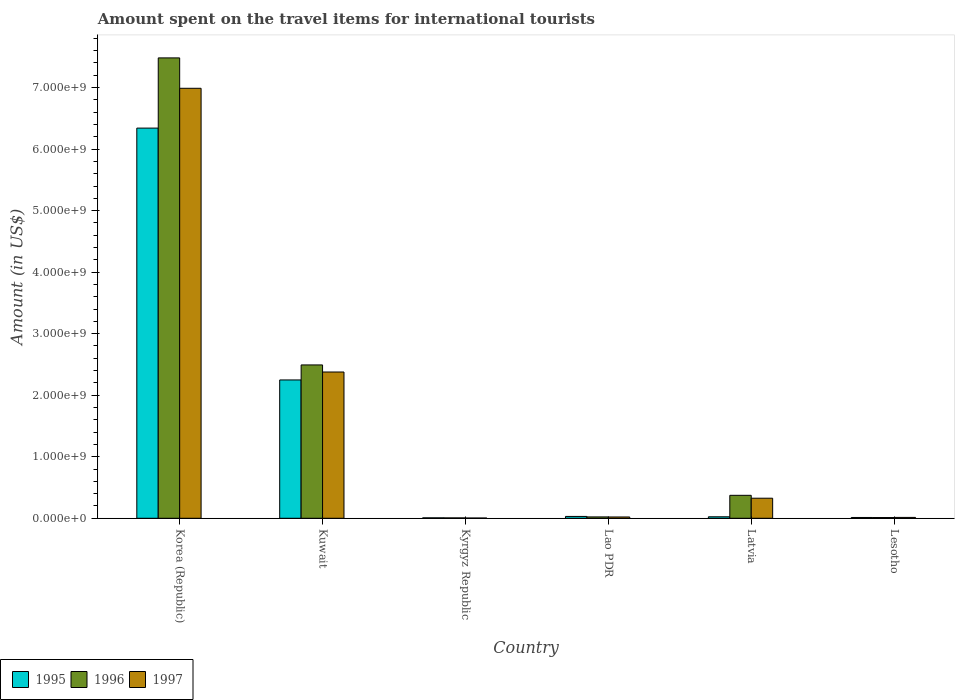How many different coloured bars are there?
Provide a succinct answer. 3. Are the number of bars on each tick of the X-axis equal?
Ensure brevity in your answer.  Yes. How many bars are there on the 6th tick from the left?
Make the answer very short. 3. What is the label of the 3rd group of bars from the left?
Offer a very short reply. Kyrgyz Republic. What is the amount spent on the travel items for international tourists in 1997 in Kuwait?
Your answer should be very brief. 2.38e+09. Across all countries, what is the maximum amount spent on the travel items for international tourists in 1995?
Make the answer very short. 6.34e+09. Across all countries, what is the minimum amount spent on the travel items for international tourists in 1995?
Offer a very short reply. 7.00e+06. In which country was the amount spent on the travel items for international tourists in 1996 maximum?
Offer a terse response. Korea (Republic). In which country was the amount spent on the travel items for international tourists in 1996 minimum?
Your response must be concise. Kyrgyz Republic. What is the total amount spent on the travel items for international tourists in 1996 in the graph?
Give a very brief answer. 1.04e+1. What is the difference between the amount spent on the travel items for international tourists in 1997 in Kuwait and that in Lesotho?
Your answer should be very brief. 2.36e+09. What is the difference between the amount spent on the travel items for international tourists in 1997 in Latvia and the amount spent on the travel items for international tourists in 1995 in Kuwait?
Offer a very short reply. -1.92e+09. What is the average amount spent on the travel items for international tourists in 1996 per country?
Provide a succinct answer. 1.73e+09. What is the difference between the amount spent on the travel items for international tourists of/in 1997 and amount spent on the travel items for international tourists of/in 1995 in Korea (Republic)?
Provide a short and direct response. 6.47e+08. What is the ratio of the amount spent on the travel items for international tourists in 1997 in Kuwait to that in Lesotho?
Your response must be concise. 169.79. Is the amount spent on the travel items for international tourists in 1996 in Korea (Republic) less than that in Lao PDR?
Provide a succinct answer. No. What is the difference between the highest and the second highest amount spent on the travel items for international tourists in 1995?
Provide a short and direct response. 4.09e+09. What is the difference between the highest and the lowest amount spent on the travel items for international tourists in 1996?
Keep it short and to the point. 7.48e+09. Is the sum of the amount spent on the travel items for international tourists in 1995 in Lao PDR and Latvia greater than the maximum amount spent on the travel items for international tourists in 1996 across all countries?
Give a very brief answer. No. What does the 3rd bar from the right in Lao PDR represents?
Give a very brief answer. 1995. Are all the bars in the graph horizontal?
Make the answer very short. No. What is the difference between two consecutive major ticks on the Y-axis?
Provide a short and direct response. 1.00e+09. Does the graph contain any zero values?
Offer a terse response. No. Does the graph contain grids?
Offer a very short reply. No. Where does the legend appear in the graph?
Offer a terse response. Bottom left. What is the title of the graph?
Ensure brevity in your answer.  Amount spent on the travel items for international tourists. What is the Amount (in US$) in 1995 in Korea (Republic)?
Your answer should be compact. 6.34e+09. What is the Amount (in US$) in 1996 in Korea (Republic)?
Give a very brief answer. 7.48e+09. What is the Amount (in US$) in 1997 in Korea (Republic)?
Offer a terse response. 6.99e+09. What is the Amount (in US$) of 1995 in Kuwait?
Ensure brevity in your answer.  2.25e+09. What is the Amount (in US$) of 1996 in Kuwait?
Ensure brevity in your answer.  2.49e+09. What is the Amount (in US$) in 1997 in Kuwait?
Ensure brevity in your answer.  2.38e+09. What is the Amount (in US$) in 1995 in Kyrgyz Republic?
Provide a short and direct response. 7.00e+06. What is the Amount (in US$) of 1995 in Lao PDR?
Your answer should be very brief. 3.00e+07. What is the Amount (in US$) of 1996 in Lao PDR?
Ensure brevity in your answer.  2.20e+07. What is the Amount (in US$) of 1997 in Lao PDR?
Give a very brief answer. 2.10e+07. What is the Amount (in US$) in 1995 in Latvia?
Provide a short and direct response. 2.40e+07. What is the Amount (in US$) of 1996 in Latvia?
Give a very brief answer. 3.73e+08. What is the Amount (in US$) of 1997 in Latvia?
Your answer should be compact. 3.26e+08. What is the Amount (in US$) in 1995 in Lesotho?
Your response must be concise. 1.30e+07. What is the Amount (in US$) of 1997 in Lesotho?
Provide a short and direct response. 1.40e+07. Across all countries, what is the maximum Amount (in US$) in 1995?
Provide a short and direct response. 6.34e+09. Across all countries, what is the maximum Amount (in US$) of 1996?
Your response must be concise. 7.48e+09. Across all countries, what is the maximum Amount (in US$) of 1997?
Give a very brief answer. 6.99e+09. Across all countries, what is the minimum Amount (in US$) in 1997?
Your answer should be very brief. 4.00e+06. What is the total Amount (in US$) in 1995 in the graph?
Your answer should be very brief. 8.66e+09. What is the total Amount (in US$) of 1996 in the graph?
Offer a very short reply. 1.04e+1. What is the total Amount (in US$) in 1997 in the graph?
Offer a terse response. 9.73e+09. What is the difference between the Amount (in US$) in 1995 in Korea (Republic) and that in Kuwait?
Ensure brevity in your answer.  4.09e+09. What is the difference between the Amount (in US$) in 1996 in Korea (Republic) and that in Kuwait?
Your response must be concise. 4.99e+09. What is the difference between the Amount (in US$) in 1997 in Korea (Republic) and that in Kuwait?
Your answer should be very brief. 4.61e+09. What is the difference between the Amount (in US$) of 1995 in Korea (Republic) and that in Kyrgyz Republic?
Ensure brevity in your answer.  6.33e+09. What is the difference between the Amount (in US$) of 1996 in Korea (Republic) and that in Kyrgyz Republic?
Offer a very short reply. 7.48e+09. What is the difference between the Amount (in US$) of 1997 in Korea (Republic) and that in Kyrgyz Republic?
Your response must be concise. 6.98e+09. What is the difference between the Amount (in US$) of 1995 in Korea (Republic) and that in Lao PDR?
Keep it short and to the point. 6.31e+09. What is the difference between the Amount (in US$) of 1996 in Korea (Republic) and that in Lao PDR?
Ensure brevity in your answer.  7.46e+09. What is the difference between the Amount (in US$) in 1997 in Korea (Republic) and that in Lao PDR?
Provide a short and direct response. 6.97e+09. What is the difference between the Amount (in US$) of 1995 in Korea (Republic) and that in Latvia?
Provide a short and direct response. 6.32e+09. What is the difference between the Amount (in US$) of 1996 in Korea (Republic) and that in Latvia?
Provide a short and direct response. 7.11e+09. What is the difference between the Amount (in US$) of 1997 in Korea (Republic) and that in Latvia?
Provide a short and direct response. 6.66e+09. What is the difference between the Amount (in US$) of 1995 in Korea (Republic) and that in Lesotho?
Your answer should be compact. 6.33e+09. What is the difference between the Amount (in US$) in 1996 in Korea (Republic) and that in Lesotho?
Provide a short and direct response. 7.47e+09. What is the difference between the Amount (in US$) of 1997 in Korea (Republic) and that in Lesotho?
Keep it short and to the point. 6.97e+09. What is the difference between the Amount (in US$) of 1995 in Kuwait and that in Kyrgyz Republic?
Keep it short and to the point. 2.24e+09. What is the difference between the Amount (in US$) in 1996 in Kuwait and that in Kyrgyz Republic?
Offer a terse response. 2.49e+09. What is the difference between the Amount (in US$) in 1997 in Kuwait and that in Kyrgyz Republic?
Ensure brevity in your answer.  2.37e+09. What is the difference between the Amount (in US$) in 1995 in Kuwait and that in Lao PDR?
Your answer should be compact. 2.22e+09. What is the difference between the Amount (in US$) in 1996 in Kuwait and that in Lao PDR?
Make the answer very short. 2.47e+09. What is the difference between the Amount (in US$) in 1997 in Kuwait and that in Lao PDR?
Provide a short and direct response. 2.36e+09. What is the difference between the Amount (in US$) of 1995 in Kuwait and that in Latvia?
Offer a terse response. 2.22e+09. What is the difference between the Amount (in US$) of 1996 in Kuwait and that in Latvia?
Offer a very short reply. 2.12e+09. What is the difference between the Amount (in US$) of 1997 in Kuwait and that in Latvia?
Offer a very short reply. 2.05e+09. What is the difference between the Amount (in US$) of 1995 in Kuwait and that in Lesotho?
Keep it short and to the point. 2.24e+09. What is the difference between the Amount (in US$) in 1996 in Kuwait and that in Lesotho?
Your answer should be compact. 2.48e+09. What is the difference between the Amount (in US$) in 1997 in Kuwait and that in Lesotho?
Provide a short and direct response. 2.36e+09. What is the difference between the Amount (in US$) in 1995 in Kyrgyz Republic and that in Lao PDR?
Offer a very short reply. -2.30e+07. What is the difference between the Amount (in US$) in 1996 in Kyrgyz Republic and that in Lao PDR?
Offer a terse response. -1.60e+07. What is the difference between the Amount (in US$) of 1997 in Kyrgyz Republic and that in Lao PDR?
Your answer should be compact. -1.70e+07. What is the difference between the Amount (in US$) in 1995 in Kyrgyz Republic and that in Latvia?
Provide a short and direct response. -1.70e+07. What is the difference between the Amount (in US$) of 1996 in Kyrgyz Republic and that in Latvia?
Give a very brief answer. -3.67e+08. What is the difference between the Amount (in US$) in 1997 in Kyrgyz Republic and that in Latvia?
Provide a succinct answer. -3.22e+08. What is the difference between the Amount (in US$) of 1995 in Kyrgyz Republic and that in Lesotho?
Provide a short and direct response. -6.00e+06. What is the difference between the Amount (in US$) of 1996 in Kyrgyz Republic and that in Lesotho?
Offer a terse response. -6.00e+06. What is the difference between the Amount (in US$) in 1997 in Kyrgyz Republic and that in Lesotho?
Your response must be concise. -1.00e+07. What is the difference between the Amount (in US$) in 1996 in Lao PDR and that in Latvia?
Give a very brief answer. -3.51e+08. What is the difference between the Amount (in US$) of 1997 in Lao PDR and that in Latvia?
Make the answer very short. -3.05e+08. What is the difference between the Amount (in US$) in 1995 in Lao PDR and that in Lesotho?
Provide a short and direct response. 1.70e+07. What is the difference between the Amount (in US$) of 1996 in Lao PDR and that in Lesotho?
Make the answer very short. 1.00e+07. What is the difference between the Amount (in US$) in 1997 in Lao PDR and that in Lesotho?
Offer a terse response. 7.00e+06. What is the difference between the Amount (in US$) in 1995 in Latvia and that in Lesotho?
Keep it short and to the point. 1.10e+07. What is the difference between the Amount (in US$) in 1996 in Latvia and that in Lesotho?
Your answer should be compact. 3.61e+08. What is the difference between the Amount (in US$) of 1997 in Latvia and that in Lesotho?
Keep it short and to the point. 3.12e+08. What is the difference between the Amount (in US$) in 1995 in Korea (Republic) and the Amount (in US$) in 1996 in Kuwait?
Offer a very short reply. 3.85e+09. What is the difference between the Amount (in US$) of 1995 in Korea (Republic) and the Amount (in US$) of 1997 in Kuwait?
Your answer should be very brief. 3.96e+09. What is the difference between the Amount (in US$) of 1996 in Korea (Republic) and the Amount (in US$) of 1997 in Kuwait?
Provide a succinct answer. 5.10e+09. What is the difference between the Amount (in US$) in 1995 in Korea (Republic) and the Amount (in US$) in 1996 in Kyrgyz Republic?
Your answer should be very brief. 6.34e+09. What is the difference between the Amount (in US$) of 1995 in Korea (Republic) and the Amount (in US$) of 1997 in Kyrgyz Republic?
Provide a short and direct response. 6.34e+09. What is the difference between the Amount (in US$) of 1996 in Korea (Republic) and the Amount (in US$) of 1997 in Kyrgyz Republic?
Provide a short and direct response. 7.48e+09. What is the difference between the Amount (in US$) of 1995 in Korea (Republic) and the Amount (in US$) of 1996 in Lao PDR?
Make the answer very short. 6.32e+09. What is the difference between the Amount (in US$) in 1995 in Korea (Republic) and the Amount (in US$) in 1997 in Lao PDR?
Give a very brief answer. 6.32e+09. What is the difference between the Amount (in US$) in 1996 in Korea (Republic) and the Amount (in US$) in 1997 in Lao PDR?
Offer a very short reply. 7.46e+09. What is the difference between the Amount (in US$) of 1995 in Korea (Republic) and the Amount (in US$) of 1996 in Latvia?
Your response must be concise. 5.97e+09. What is the difference between the Amount (in US$) in 1995 in Korea (Republic) and the Amount (in US$) in 1997 in Latvia?
Make the answer very short. 6.02e+09. What is the difference between the Amount (in US$) in 1996 in Korea (Republic) and the Amount (in US$) in 1997 in Latvia?
Provide a succinct answer. 7.16e+09. What is the difference between the Amount (in US$) of 1995 in Korea (Republic) and the Amount (in US$) of 1996 in Lesotho?
Your answer should be compact. 6.33e+09. What is the difference between the Amount (in US$) of 1995 in Korea (Republic) and the Amount (in US$) of 1997 in Lesotho?
Provide a short and direct response. 6.33e+09. What is the difference between the Amount (in US$) in 1996 in Korea (Republic) and the Amount (in US$) in 1997 in Lesotho?
Offer a very short reply. 7.47e+09. What is the difference between the Amount (in US$) in 1995 in Kuwait and the Amount (in US$) in 1996 in Kyrgyz Republic?
Offer a terse response. 2.24e+09. What is the difference between the Amount (in US$) of 1995 in Kuwait and the Amount (in US$) of 1997 in Kyrgyz Republic?
Your answer should be very brief. 2.24e+09. What is the difference between the Amount (in US$) in 1996 in Kuwait and the Amount (in US$) in 1997 in Kyrgyz Republic?
Keep it short and to the point. 2.49e+09. What is the difference between the Amount (in US$) of 1995 in Kuwait and the Amount (in US$) of 1996 in Lao PDR?
Offer a very short reply. 2.23e+09. What is the difference between the Amount (in US$) of 1995 in Kuwait and the Amount (in US$) of 1997 in Lao PDR?
Offer a terse response. 2.23e+09. What is the difference between the Amount (in US$) in 1996 in Kuwait and the Amount (in US$) in 1997 in Lao PDR?
Ensure brevity in your answer.  2.47e+09. What is the difference between the Amount (in US$) in 1995 in Kuwait and the Amount (in US$) in 1996 in Latvia?
Offer a very short reply. 1.88e+09. What is the difference between the Amount (in US$) in 1995 in Kuwait and the Amount (in US$) in 1997 in Latvia?
Your response must be concise. 1.92e+09. What is the difference between the Amount (in US$) in 1996 in Kuwait and the Amount (in US$) in 1997 in Latvia?
Your answer should be very brief. 2.17e+09. What is the difference between the Amount (in US$) in 1995 in Kuwait and the Amount (in US$) in 1996 in Lesotho?
Make the answer very short. 2.24e+09. What is the difference between the Amount (in US$) of 1995 in Kuwait and the Amount (in US$) of 1997 in Lesotho?
Make the answer very short. 2.23e+09. What is the difference between the Amount (in US$) in 1996 in Kuwait and the Amount (in US$) in 1997 in Lesotho?
Offer a terse response. 2.48e+09. What is the difference between the Amount (in US$) of 1995 in Kyrgyz Republic and the Amount (in US$) of 1996 in Lao PDR?
Keep it short and to the point. -1.50e+07. What is the difference between the Amount (in US$) of 1995 in Kyrgyz Republic and the Amount (in US$) of 1997 in Lao PDR?
Your answer should be very brief. -1.40e+07. What is the difference between the Amount (in US$) of 1996 in Kyrgyz Republic and the Amount (in US$) of 1997 in Lao PDR?
Your answer should be compact. -1.50e+07. What is the difference between the Amount (in US$) in 1995 in Kyrgyz Republic and the Amount (in US$) in 1996 in Latvia?
Keep it short and to the point. -3.66e+08. What is the difference between the Amount (in US$) in 1995 in Kyrgyz Republic and the Amount (in US$) in 1997 in Latvia?
Keep it short and to the point. -3.19e+08. What is the difference between the Amount (in US$) of 1996 in Kyrgyz Republic and the Amount (in US$) of 1997 in Latvia?
Your answer should be very brief. -3.20e+08. What is the difference between the Amount (in US$) in 1995 in Kyrgyz Republic and the Amount (in US$) in 1996 in Lesotho?
Make the answer very short. -5.00e+06. What is the difference between the Amount (in US$) in 1995 in Kyrgyz Republic and the Amount (in US$) in 1997 in Lesotho?
Your answer should be compact. -7.00e+06. What is the difference between the Amount (in US$) in 1996 in Kyrgyz Republic and the Amount (in US$) in 1997 in Lesotho?
Offer a terse response. -8.00e+06. What is the difference between the Amount (in US$) of 1995 in Lao PDR and the Amount (in US$) of 1996 in Latvia?
Your answer should be compact. -3.43e+08. What is the difference between the Amount (in US$) of 1995 in Lao PDR and the Amount (in US$) of 1997 in Latvia?
Provide a succinct answer. -2.96e+08. What is the difference between the Amount (in US$) in 1996 in Lao PDR and the Amount (in US$) in 1997 in Latvia?
Give a very brief answer. -3.04e+08. What is the difference between the Amount (in US$) of 1995 in Lao PDR and the Amount (in US$) of 1996 in Lesotho?
Your answer should be very brief. 1.80e+07. What is the difference between the Amount (in US$) in 1995 in Lao PDR and the Amount (in US$) in 1997 in Lesotho?
Offer a very short reply. 1.60e+07. What is the difference between the Amount (in US$) in 1996 in Lao PDR and the Amount (in US$) in 1997 in Lesotho?
Keep it short and to the point. 8.00e+06. What is the difference between the Amount (in US$) of 1995 in Latvia and the Amount (in US$) of 1996 in Lesotho?
Keep it short and to the point. 1.20e+07. What is the difference between the Amount (in US$) in 1996 in Latvia and the Amount (in US$) in 1997 in Lesotho?
Give a very brief answer. 3.59e+08. What is the average Amount (in US$) in 1995 per country?
Your response must be concise. 1.44e+09. What is the average Amount (in US$) in 1996 per country?
Your answer should be compact. 1.73e+09. What is the average Amount (in US$) in 1997 per country?
Provide a short and direct response. 1.62e+09. What is the difference between the Amount (in US$) of 1995 and Amount (in US$) of 1996 in Korea (Republic)?
Keep it short and to the point. -1.14e+09. What is the difference between the Amount (in US$) of 1995 and Amount (in US$) of 1997 in Korea (Republic)?
Offer a terse response. -6.47e+08. What is the difference between the Amount (in US$) of 1996 and Amount (in US$) of 1997 in Korea (Republic)?
Offer a terse response. 4.94e+08. What is the difference between the Amount (in US$) of 1995 and Amount (in US$) of 1996 in Kuwait?
Ensure brevity in your answer.  -2.44e+08. What is the difference between the Amount (in US$) in 1995 and Amount (in US$) in 1997 in Kuwait?
Offer a terse response. -1.29e+08. What is the difference between the Amount (in US$) in 1996 and Amount (in US$) in 1997 in Kuwait?
Offer a very short reply. 1.15e+08. What is the difference between the Amount (in US$) in 1995 and Amount (in US$) in 1997 in Kyrgyz Republic?
Ensure brevity in your answer.  3.00e+06. What is the difference between the Amount (in US$) of 1995 and Amount (in US$) of 1997 in Lao PDR?
Offer a very short reply. 9.00e+06. What is the difference between the Amount (in US$) of 1995 and Amount (in US$) of 1996 in Latvia?
Your response must be concise. -3.49e+08. What is the difference between the Amount (in US$) in 1995 and Amount (in US$) in 1997 in Latvia?
Your answer should be very brief. -3.02e+08. What is the difference between the Amount (in US$) of 1996 and Amount (in US$) of 1997 in Latvia?
Your response must be concise. 4.70e+07. What is the ratio of the Amount (in US$) in 1995 in Korea (Republic) to that in Kuwait?
Your answer should be compact. 2.82. What is the ratio of the Amount (in US$) in 1996 in Korea (Republic) to that in Kuwait?
Offer a very short reply. 3. What is the ratio of the Amount (in US$) of 1997 in Korea (Republic) to that in Kuwait?
Give a very brief answer. 2.94. What is the ratio of the Amount (in US$) in 1995 in Korea (Republic) to that in Kyrgyz Republic?
Offer a very short reply. 905.86. What is the ratio of the Amount (in US$) in 1996 in Korea (Republic) to that in Kyrgyz Republic?
Offer a very short reply. 1247. What is the ratio of the Amount (in US$) of 1997 in Korea (Republic) to that in Kyrgyz Republic?
Keep it short and to the point. 1747. What is the ratio of the Amount (in US$) in 1995 in Korea (Republic) to that in Lao PDR?
Your answer should be compact. 211.37. What is the ratio of the Amount (in US$) of 1996 in Korea (Republic) to that in Lao PDR?
Make the answer very short. 340.09. What is the ratio of the Amount (in US$) in 1997 in Korea (Republic) to that in Lao PDR?
Keep it short and to the point. 332.76. What is the ratio of the Amount (in US$) of 1995 in Korea (Republic) to that in Latvia?
Your answer should be very brief. 264.21. What is the ratio of the Amount (in US$) of 1996 in Korea (Republic) to that in Latvia?
Offer a terse response. 20.06. What is the ratio of the Amount (in US$) in 1997 in Korea (Republic) to that in Latvia?
Offer a terse response. 21.44. What is the ratio of the Amount (in US$) of 1995 in Korea (Republic) to that in Lesotho?
Ensure brevity in your answer.  487.77. What is the ratio of the Amount (in US$) of 1996 in Korea (Republic) to that in Lesotho?
Offer a terse response. 623.5. What is the ratio of the Amount (in US$) of 1997 in Korea (Republic) to that in Lesotho?
Your answer should be compact. 499.14. What is the ratio of the Amount (in US$) in 1995 in Kuwait to that in Kyrgyz Republic?
Your answer should be very brief. 321.14. What is the ratio of the Amount (in US$) in 1996 in Kuwait to that in Kyrgyz Republic?
Offer a terse response. 415.33. What is the ratio of the Amount (in US$) of 1997 in Kuwait to that in Kyrgyz Republic?
Keep it short and to the point. 594.25. What is the ratio of the Amount (in US$) in 1995 in Kuwait to that in Lao PDR?
Your answer should be compact. 74.93. What is the ratio of the Amount (in US$) in 1996 in Kuwait to that in Lao PDR?
Offer a very short reply. 113.27. What is the ratio of the Amount (in US$) in 1997 in Kuwait to that in Lao PDR?
Keep it short and to the point. 113.19. What is the ratio of the Amount (in US$) of 1995 in Kuwait to that in Latvia?
Make the answer very short. 93.67. What is the ratio of the Amount (in US$) in 1996 in Kuwait to that in Latvia?
Make the answer very short. 6.68. What is the ratio of the Amount (in US$) in 1997 in Kuwait to that in Latvia?
Your response must be concise. 7.29. What is the ratio of the Amount (in US$) of 1995 in Kuwait to that in Lesotho?
Offer a very short reply. 172.92. What is the ratio of the Amount (in US$) in 1996 in Kuwait to that in Lesotho?
Your response must be concise. 207.67. What is the ratio of the Amount (in US$) in 1997 in Kuwait to that in Lesotho?
Keep it short and to the point. 169.79. What is the ratio of the Amount (in US$) of 1995 in Kyrgyz Republic to that in Lao PDR?
Provide a short and direct response. 0.23. What is the ratio of the Amount (in US$) of 1996 in Kyrgyz Republic to that in Lao PDR?
Offer a terse response. 0.27. What is the ratio of the Amount (in US$) of 1997 in Kyrgyz Republic to that in Lao PDR?
Provide a short and direct response. 0.19. What is the ratio of the Amount (in US$) of 1995 in Kyrgyz Republic to that in Latvia?
Your response must be concise. 0.29. What is the ratio of the Amount (in US$) in 1996 in Kyrgyz Republic to that in Latvia?
Offer a terse response. 0.02. What is the ratio of the Amount (in US$) in 1997 in Kyrgyz Republic to that in Latvia?
Offer a very short reply. 0.01. What is the ratio of the Amount (in US$) of 1995 in Kyrgyz Republic to that in Lesotho?
Make the answer very short. 0.54. What is the ratio of the Amount (in US$) of 1996 in Kyrgyz Republic to that in Lesotho?
Your answer should be very brief. 0.5. What is the ratio of the Amount (in US$) of 1997 in Kyrgyz Republic to that in Lesotho?
Keep it short and to the point. 0.29. What is the ratio of the Amount (in US$) of 1996 in Lao PDR to that in Latvia?
Give a very brief answer. 0.06. What is the ratio of the Amount (in US$) in 1997 in Lao PDR to that in Latvia?
Provide a short and direct response. 0.06. What is the ratio of the Amount (in US$) of 1995 in Lao PDR to that in Lesotho?
Offer a terse response. 2.31. What is the ratio of the Amount (in US$) of 1996 in Lao PDR to that in Lesotho?
Provide a short and direct response. 1.83. What is the ratio of the Amount (in US$) of 1995 in Latvia to that in Lesotho?
Ensure brevity in your answer.  1.85. What is the ratio of the Amount (in US$) of 1996 in Latvia to that in Lesotho?
Offer a terse response. 31.08. What is the ratio of the Amount (in US$) of 1997 in Latvia to that in Lesotho?
Your response must be concise. 23.29. What is the difference between the highest and the second highest Amount (in US$) in 1995?
Your answer should be compact. 4.09e+09. What is the difference between the highest and the second highest Amount (in US$) of 1996?
Your answer should be very brief. 4.99e+09. What is the difference between the highest and the second highest Amount (in US$) in 1997?
Your answer should be very brief. 4.61e+09. What is the difference between the highest and the lowest Amount (in US$) of 1995?
Keep it short and to the point. 6.33e+09. What is the difference between the highest and the lowest Amount (in US$) in 1996?
Give a very brief answer. 7.48e+09. What is the difference between the highest and the lowest Amount (in US$) in 1997?
Provide a succinct answer. 6.98e+09. 